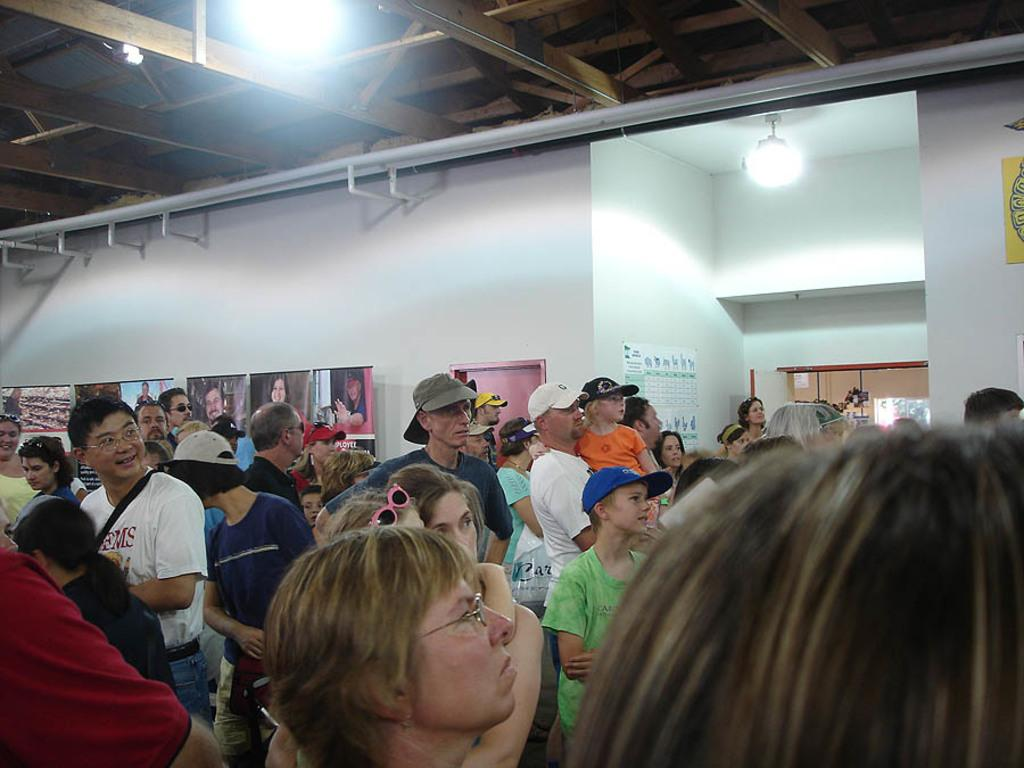What is the color of the wall in the image? The wall in the image is white. What can be seen hanging on the wall? There are lights and banners in the image. Are there any people present in the image? Yes, there are people in the image. What type of underwear is being worn by the people in the image? There is no information about the type of underwear being worn by the people in the image, as it is not visible or mentioned in the facts provided. 